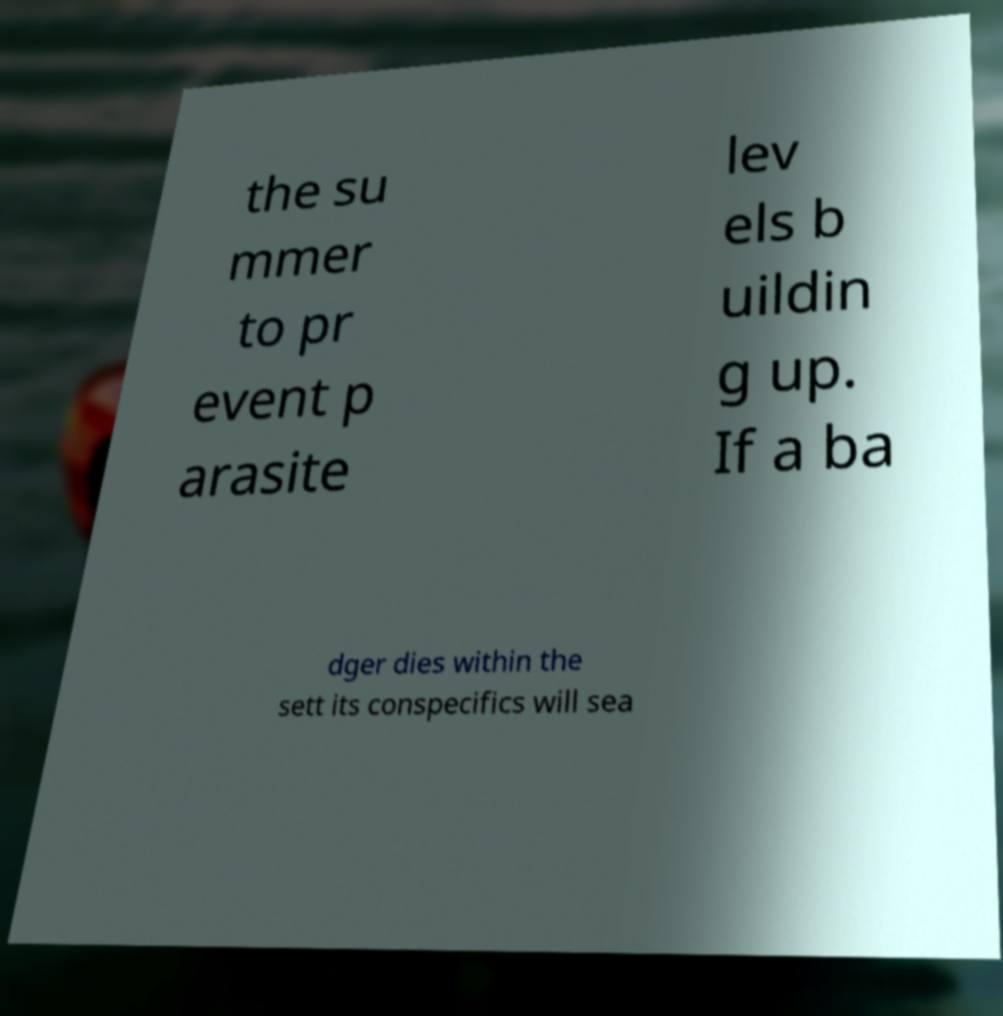Please identify and transcribe the text found in this image. the su mmer to pr event p arasite lev els b uildin g up. If a ba dger dies within the sett its conspecifics will sea 